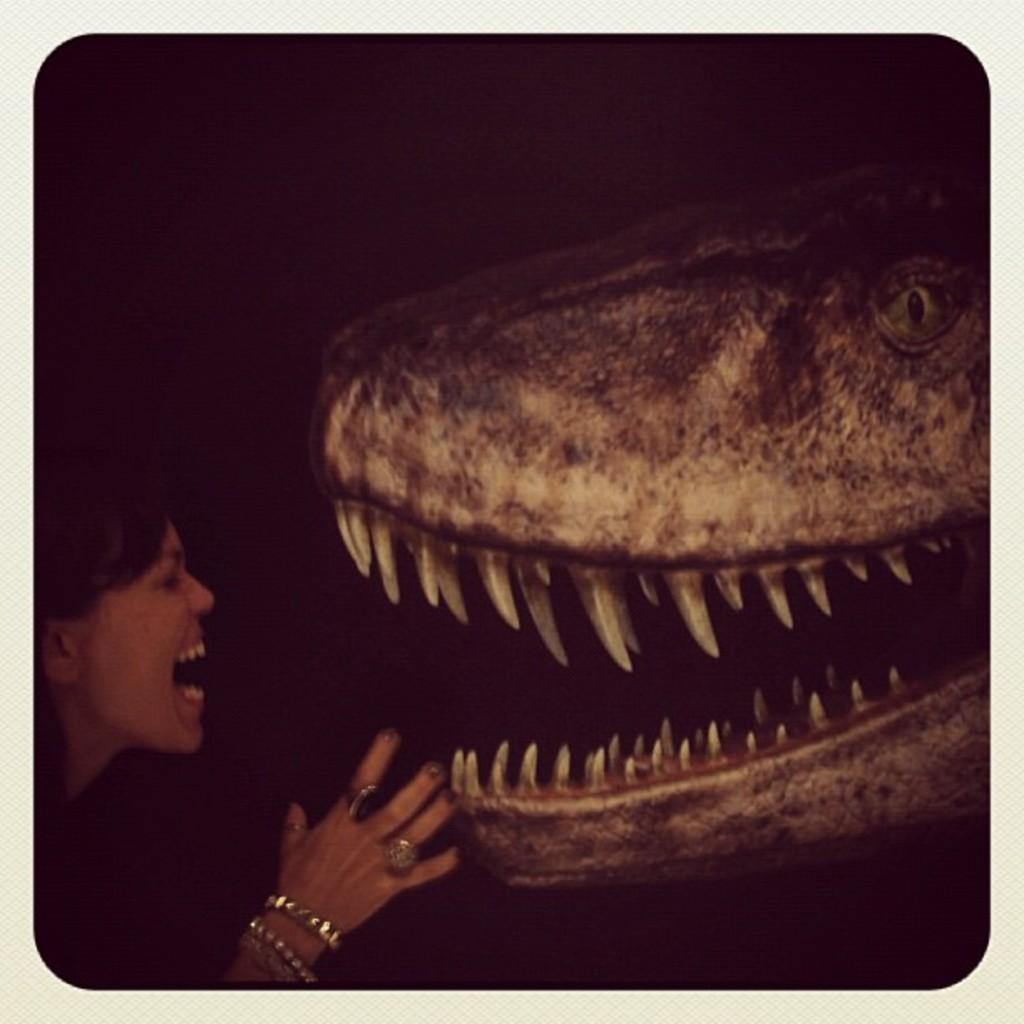What is the main subject of the image? There is a person in the image. What is the person doing in the image? The person is standing near an animal. What type of wire is the person holding in the image? There is no wire present in the image. What is the person's occupation, and are they talking to the animal in the image? The person's occupation is not mentioned in the image, and there is no indication that they are talking to the animal. 